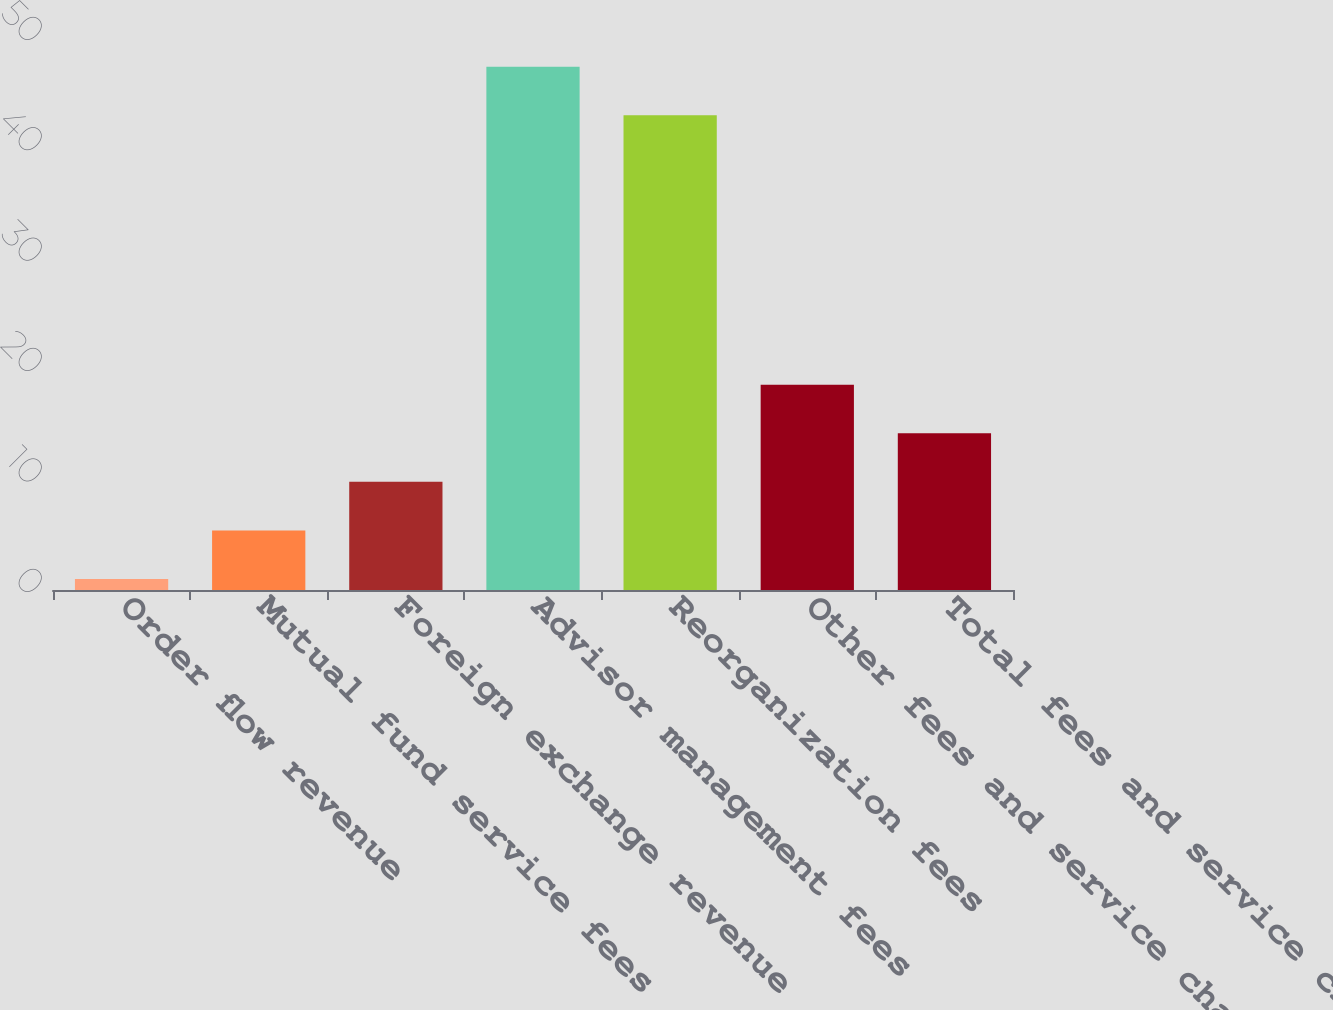Convert chart to OTSL. <chart><loc_0><loc_0><loc_500><loc_500><bar_chart><fcel>Order flow revenue<fcel>Mutual fund service fees<fcel>Foreign exchange revenue<fcel>Advisor management fees<fcel>Reorganization fees<fcel>Other fees and service charges<fcel>Total fees and service charges<nl><fcel>1<fcel>5.4<fcel>9.8<fcel>47.4<fcel>43<fcel>18.6<fcel>14.2<nl></chart> 